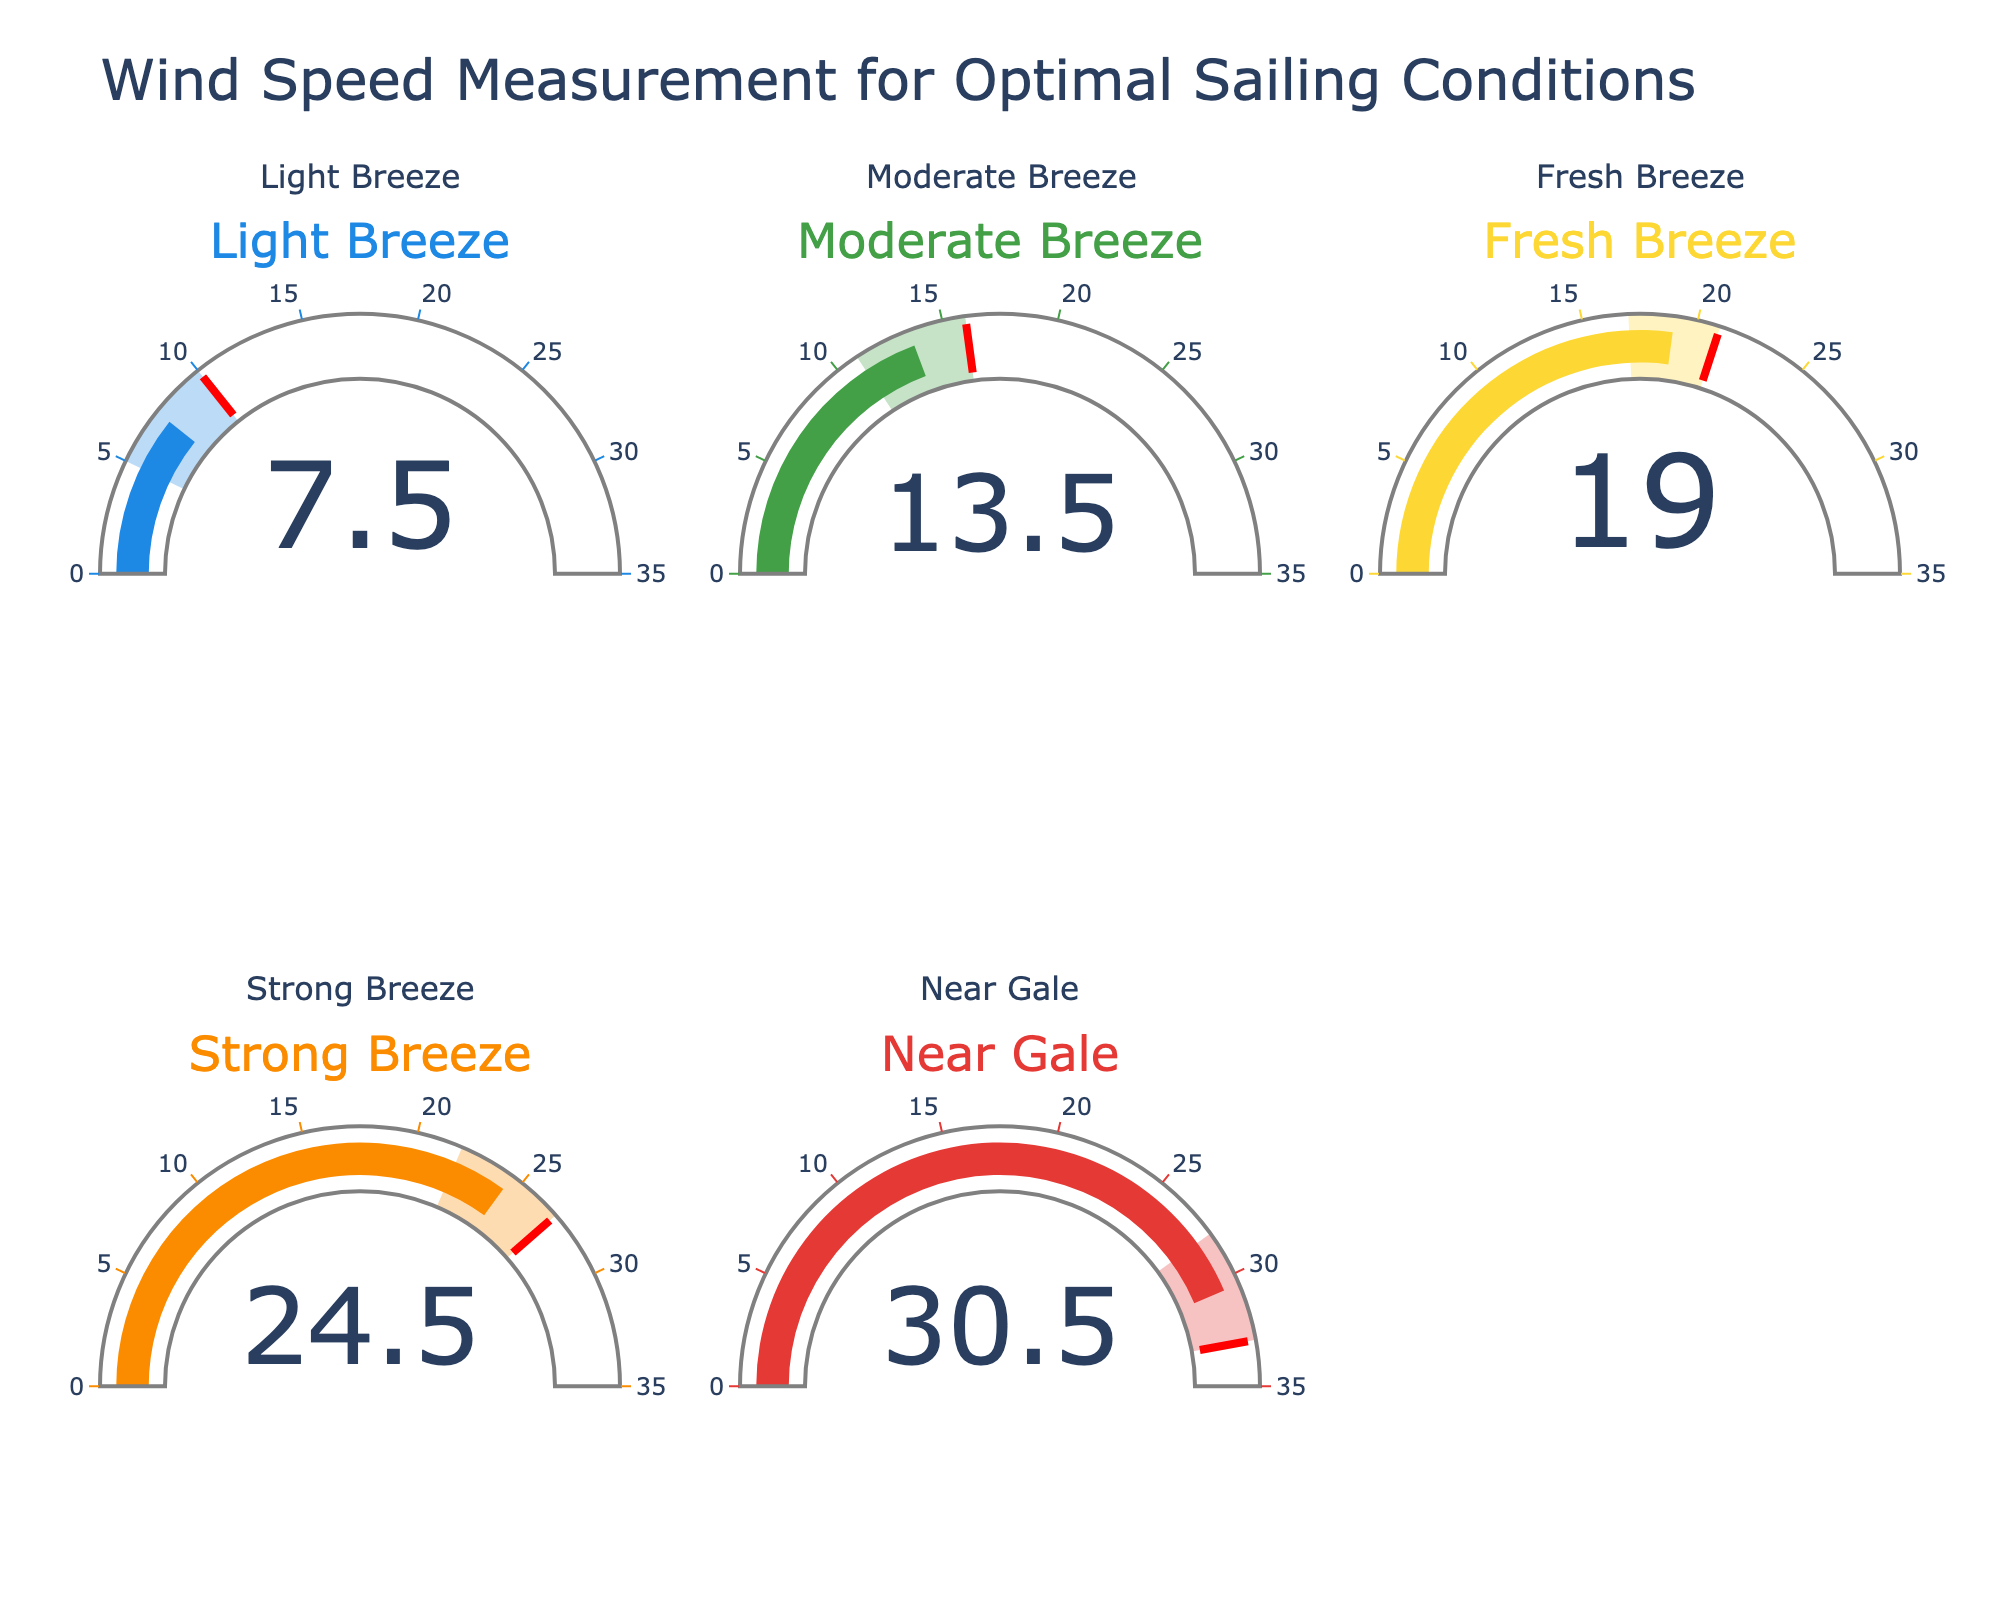What is the title of the figure? The title can be found at the top of the figure, typically in a larger font size for visibility. The title of this figure is "Wind Speed Measurement for Optimal Sailing Conditions"
Answer: Wind Speed Measurement for Optimal Sailing Conditions How many gauge charts are included in the figure? By visually scanning the figure, you can see there are five individual gauge charts, each corresponding to different wind speed categories.
Answer: 5 What is the ideal wind speed range for a "Moderate Breeze"? Refer to the "Moderate Breeze" gauge, where the range is indicated on the gauge. The range for a "Moderate Breeze" is from 11 to 16 knots.
Answer: 11-16 knots Which wind speed category has the highest ideal wind speed range? By examining the maximum values displayed on each gauge, you can see that the "Near Gale" category has the highest ideal range, ending at 33 knots.
Answer: Near Gale What is the average wind speed for the "Fresh Breeze" category displayed on its gauge? The "Fresh Breeze" gauge has a range from 17 to 21 knots. The average is calculated as (17 + 21) / 2 to get the mean.
Answer: 19 Between "Light Breeze" and "Strong Breeze," which category has a higher maximum ideal wind speed? By comparing the maximum values indicated on both gauges, "Light Breeze" ends at 10 knots, while "Strong Breeze" ends at 27 knots. Therefore, "Strong Breeze" has the higher maximum ideal wind speed.
Answer: Strong Breeze How does the visual style (color) differ for the "Strong Breeze" gauge compared to the "Light Breeze" gauge? The colors of the gauge can be visually inspected. The "Strong Breeze" gauge uses an orange color, while the "Light Breeze" gauge uses a blue color.
Answer: Strong Breeze uses orange; Light Breeze uses blue Calculate the median value of the ideal range for "Near Gale." The ideal range for "Near Gale" is 28 to 33 knots. The median is the middle number, which in this case would be the average of 28 and 33, computed as (28 + 33) / 2.
Answer: 30.5 Which two categories have the closest mean wind speeds? Compare the mean values displayed on each gauge. "Light Breeze" has a mean of 7.5 knots, "Moderate Breeze" has 13.5 knots, "Fresh Breeze" has 19 knots, "Strong Breeze" has 24.5 knots, and "Near Gale" has 30.5 knots. "Moderate Breeze" (13.5) and "Fresh Breeze" (19) are closest to each other.
Answer: Moderate Breeze and Fresh Breeze What is the step size and direction of the transition in the "Moderate Breeze" range, from lowest to highest value? The "Moderate Breeze" range goes from 11 to 16 knots; the step size is 1 knot per unit increment. The direction is increasing from the lower value to the higher value.
Answer: 1 knot increment, increasing 